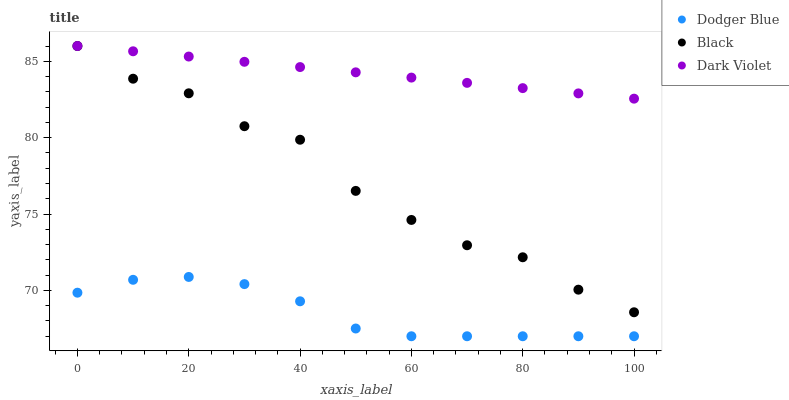Does Dodger Blue have the minimum area under the curve?
Answer yes or no. Yes. Does Dark Violet have the maximum area under the curve?
Answer yes or no. Yes. Does Dark Violet have the minimum area under the curve?
Answer yes or no. No. Does Dodger Blue have the maximum area under the curve?
Answer yes or no. No. Is Dark Violet the smoothest?
Answer yes or no. Yes. Is Black the roughest?
Answer yes or no. Yes. Is Dodger Blue the smoothest?
Answer yes or no. No. Is Dodger Blue the roughest?
Answer yes or no. No. Does Dodger Blue have the lowest value?
Answer yes or no. Yes. Does Dark Violet have the lowest value?
Answer yes or no. No. Does Dark Violet have the highest value?
Answer yes or no. Yes. Does Dodger Blue have the highest value?
Answer yes or no. No. Is Dodger Blue less than Black?
Answer yes or no. Yes. Is Dark Violet greater than Dodger Blue?
Answer yes or no. Yes. Does Dark Violet intersect Black?
Answer yes or no. Yes. Is Dark Violet less than Black?
Answer yes or no. No. Is Dark Violet greater than Black?
Answer yes or no. No. Does Dodger Blue intersect Black?
Answer yes or no. No. 